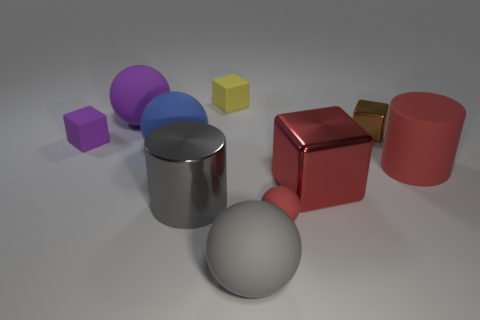Subtract 1 cubes. How many cubes are left? 3 Subtract all blocks. How many objects are left? 6 Subtract 1 yellow blocks. How many objects are left? 9 Subtract all gray cylinders. Subtract all large yellow spheres. How many objects are left? 9 Add 9 large shiny cubes. How many large shiny cubes are left? 10 Add 2 rubber spheres. How many rubber spheres exist? 6 